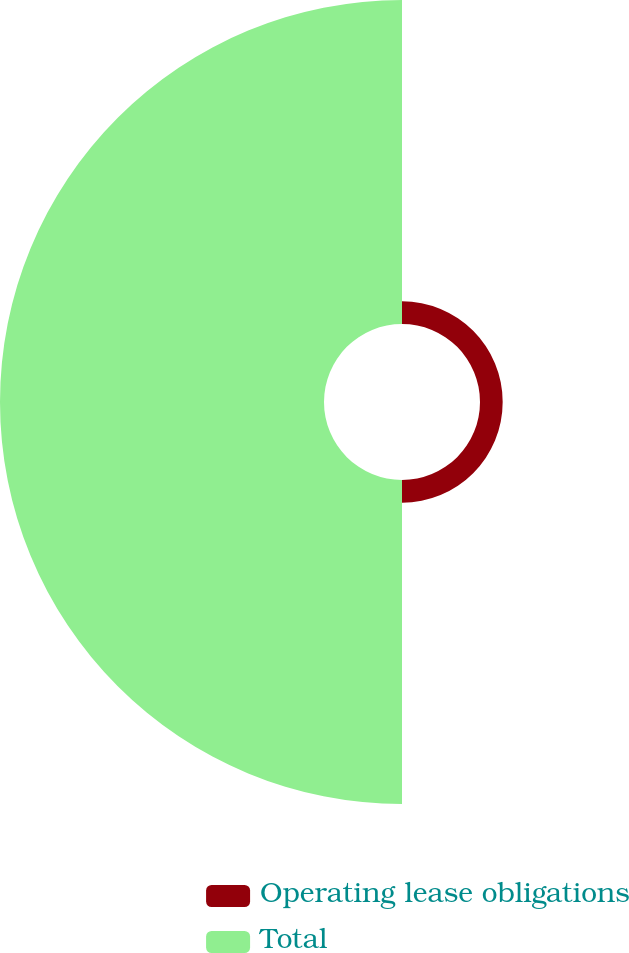Convert chart to OTSL. <chart><loc_0><loc_0><loc_500><loc_500><pie_chart><fcel>Operating lease obligations<fcel>Total<nl><fcel>6.54%<fcel>93.46%<nl></chart> 